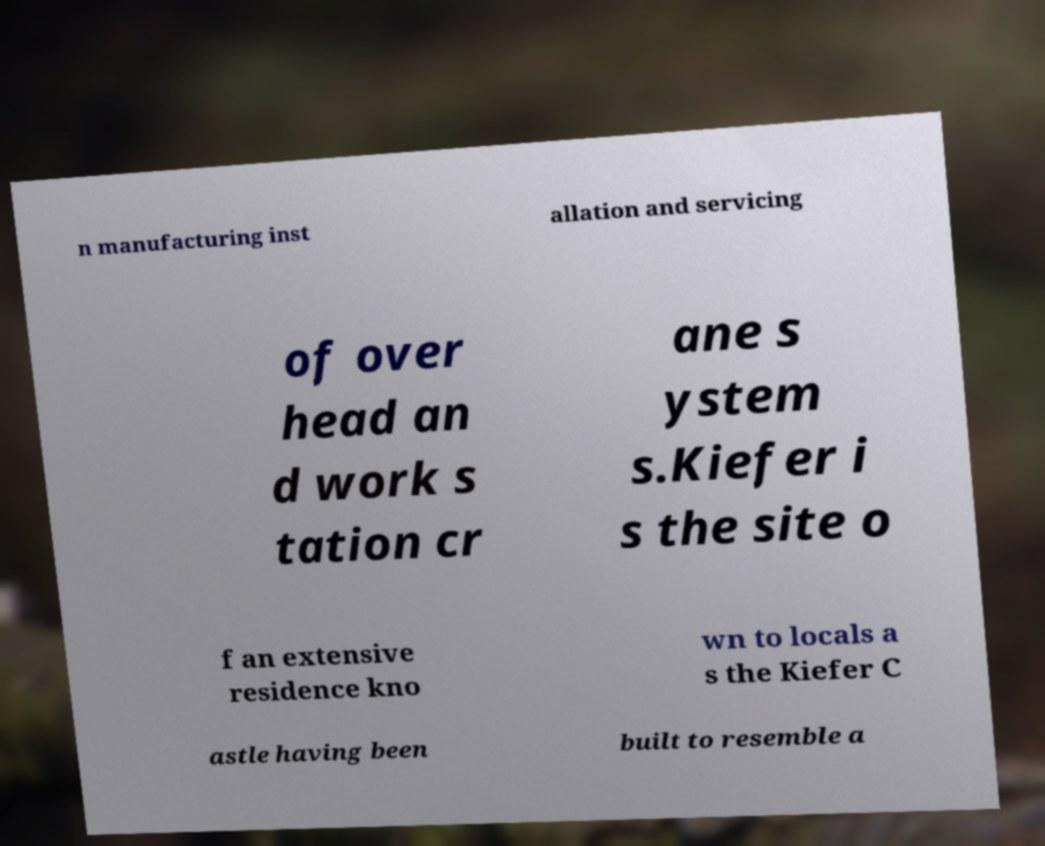Can you accurately transcribe the text from the provided image for me? n manufacturing inst allation and servicing of over head an d work s tation cr ane s ystem s.Kiefer i s the site o f an extensive residence kno wn to locals a s the Kiefer C astle having been built to resemble a 